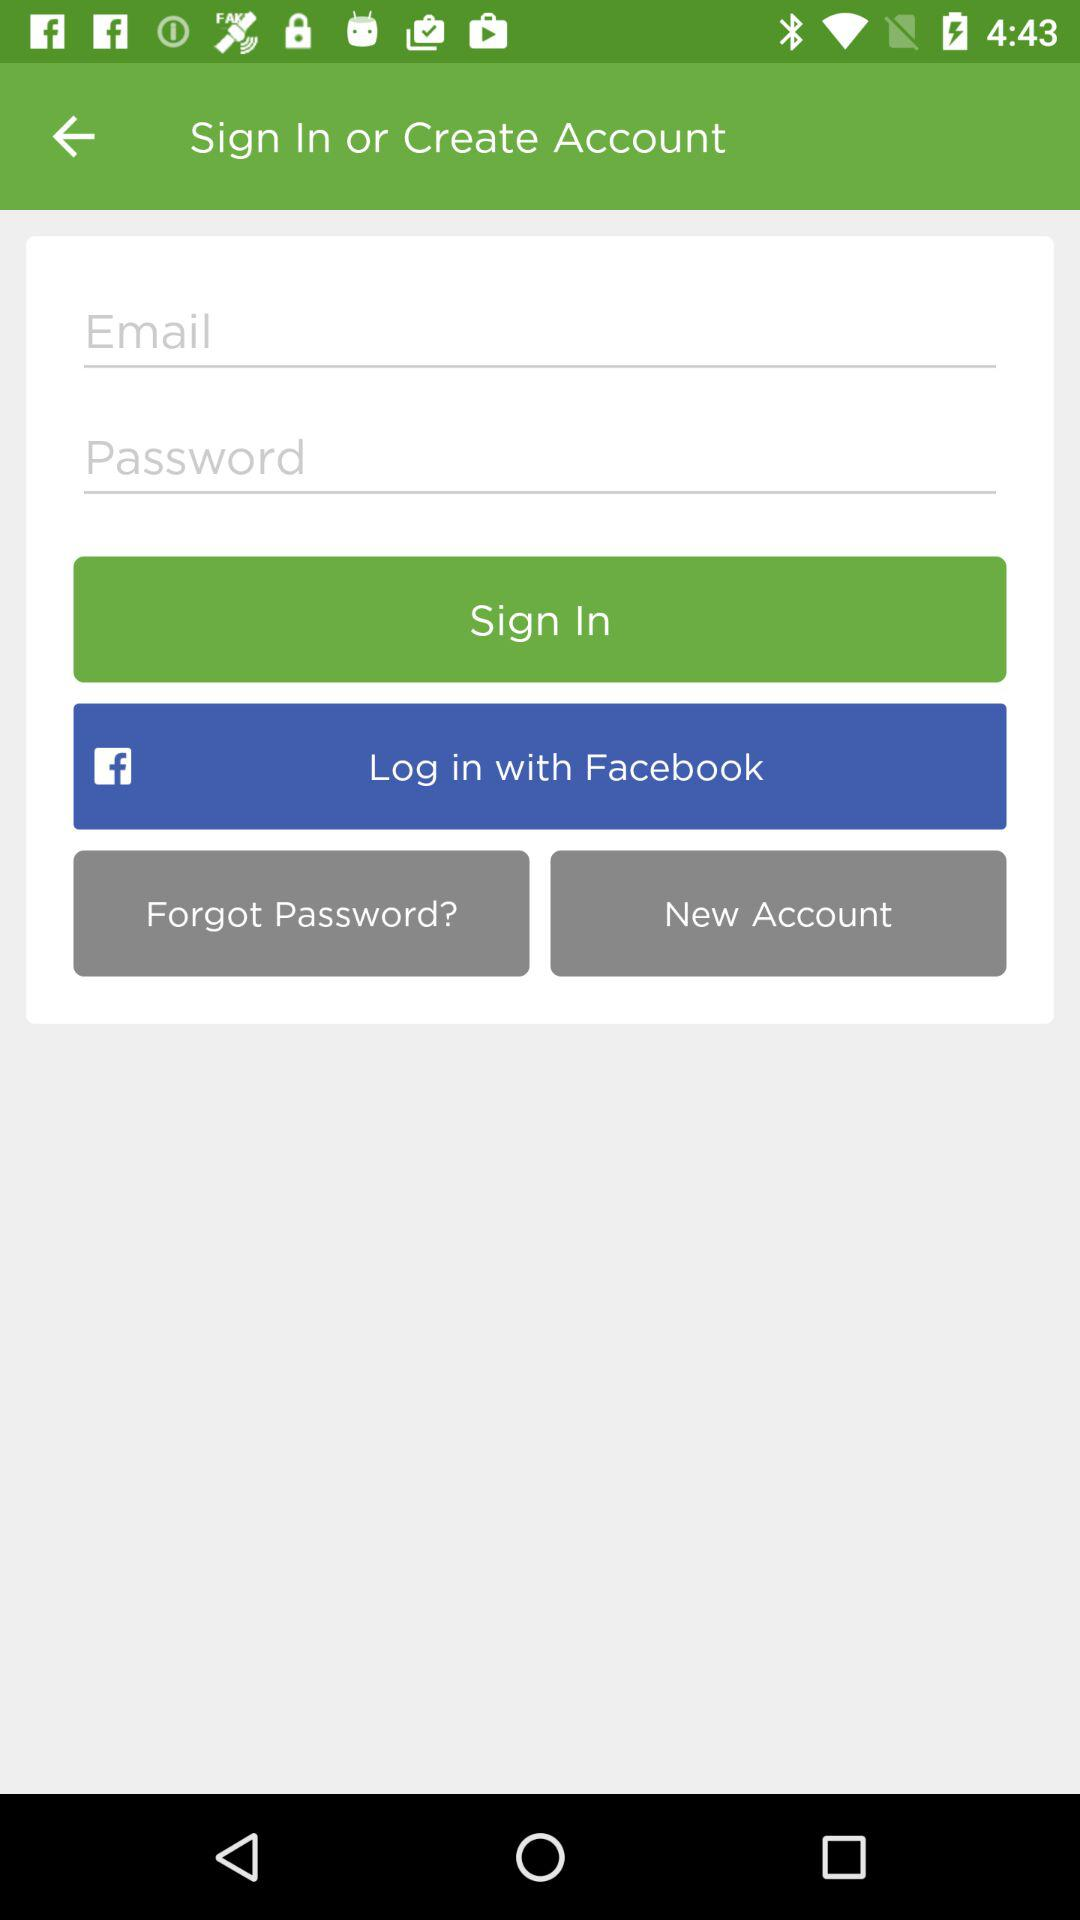What are the requirements to log in? The requirements are "Email" and "Password". 